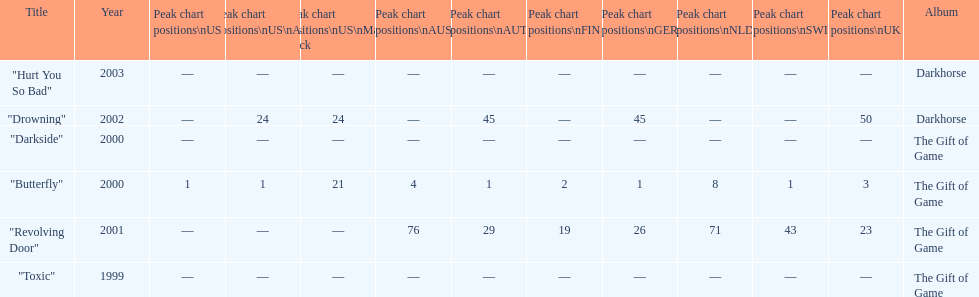How many singles have a ranking of 1 under ger? 1. 